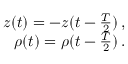<formula> <loc_0><loc_0><loc_500><loc_500>\begin{array} { r } { z ( t ) = - z ( t - \frac { T } { 2 } ) \, , } \\ { \rho ( t ) = \rho ( t - \frac { T } { 2 } ) \, . } \end{array}</formula> 